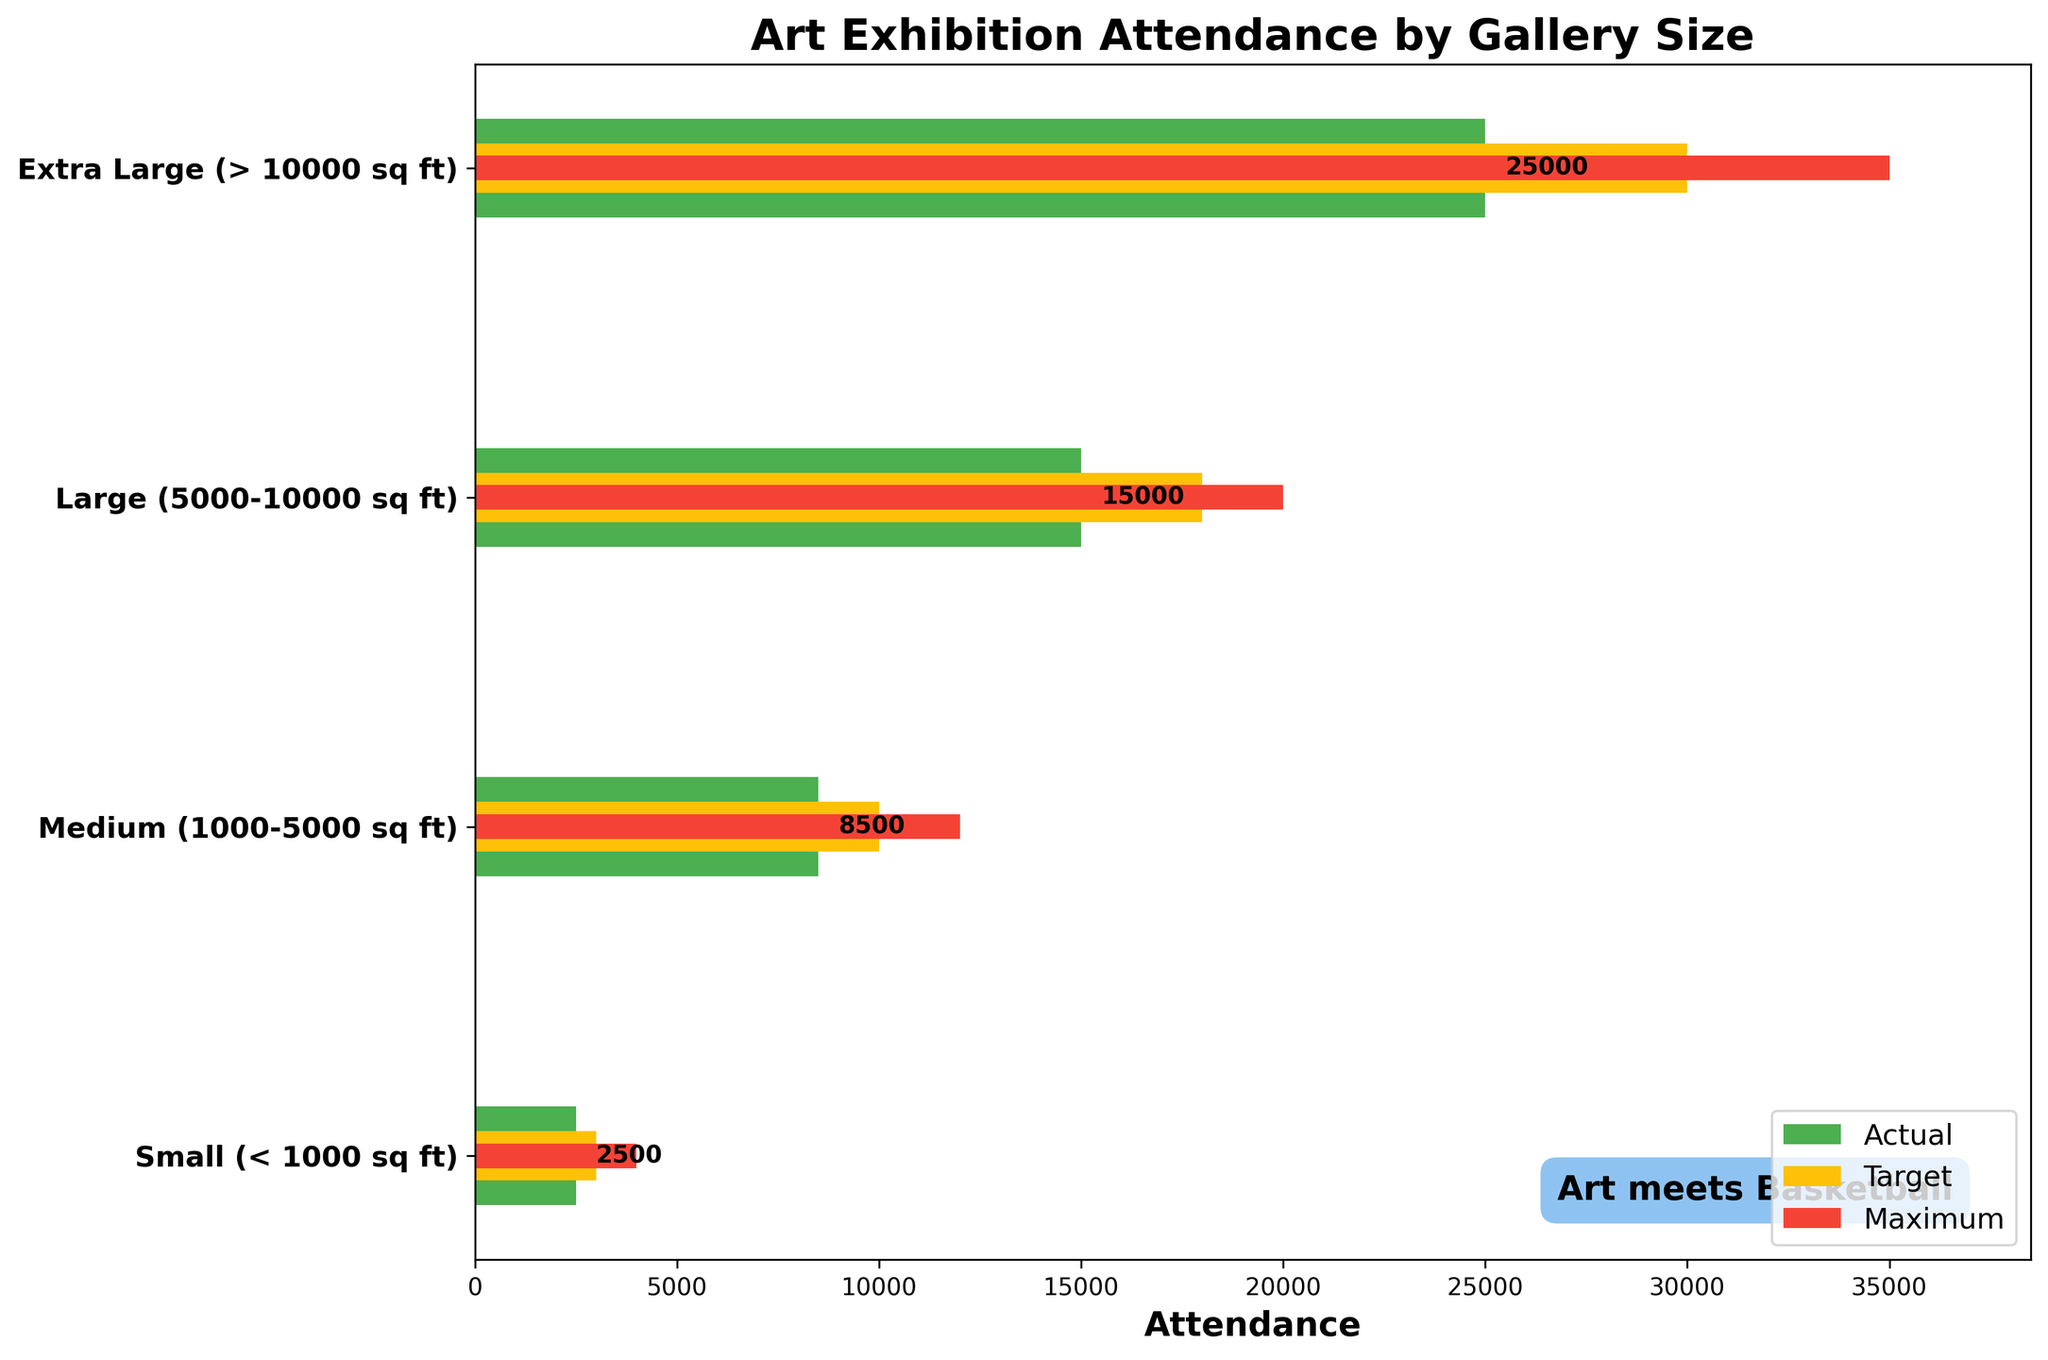What is the title of the chart? The title of the chart is found at the top of the figure; it states the main subject or purpose of the chart.
Answer: Art Exhibition Attendance by Gallery Size Which gallery size has the highest actual attendance? Look at the green bars representing actual attendance. The longest green bar indicates the gallery size with the highest actual attendance.
Answer: Extra Large (> 10000 sq ft) How does the target attendance for the 'Medium' size gallery compare to its actual attendance? Compare the yellow bar (target attendance) and the green bar (actual attendance) for the 'Medium' gallery size. The target bar is longer than the actual bar.
Answer: The target attendance is higher than the actual attendance What is the maximum capacity for the 'Large' gallery size? Look at the length of the red bar representing the maximum capacity for the 'Large' gallery size. The label on the x-axis corresponding to the end of this bar shows the capacity.
Answer: 20000 Which gallery size has the smallest difference between actual and target attendance? Calculate the difference between the yellow bars (target) and green bars (actual) for each gallery size. Identify the gallery size with the smallest difference.
Answer: Small (< 1000 sq ft) By how much did the actual attendance fall short of the target attendance for the 'Extra Large' gallery size? Subtract the value of the actual attendance (green bar) from the target attendance (yellow bar) for the 'Extra Large' gallery size.
Answer: 5000 What are the colors used to represent the actual, target, and maximum capacity values? Identify the colors of the bars: green for actual attendance, yellow for target attendance, and red for maximum capacity.
Answer: Green, Yellow, Red If you sum up the actual attendance for all gallery sizes, what value do you get? Add up the actual attendance values for all gallery sizes: 2500 (Small) + 8500 (Medium) + 15000 (Large) + 25000 (Extra Large).
Answer: 51000 Which gallery size has a target attendance of 10000? Identify the gallery size corresponding to the length of the yellow bar indicating 10000 for target attendance.
Answer: Medium (1000-5000 sq ft) How does the maximum capacity for 'Small' galleries compare to the target attendance for 'Large' galleries? Locate the red bar representing the maximum capacity of 'Small' galleries and compare its length to the yellow bar representing the target attendance for 'Large' galleries. The target attendance for 'Large' galleries is larger.
Answer: The target attendance for 'Large' galleries is higher 